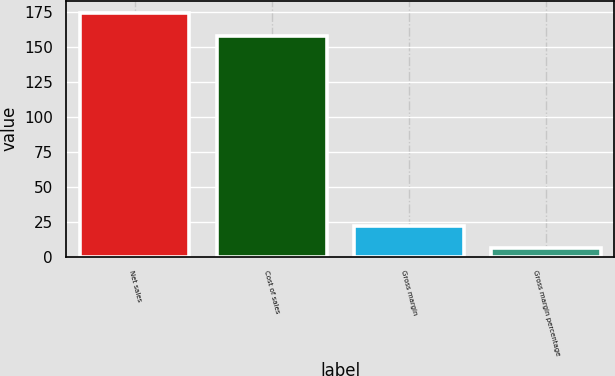<chart> <loc_0><loc_0><loc_500><loc_500><bar_chart><fcel>Net sales<fcel>Cost of sales<fcel>Gross margin<fcel>Gross margin percentage<nl><fcel>174.2<fcel>158<fcel>22.2<fcel>6<nl></chart> 